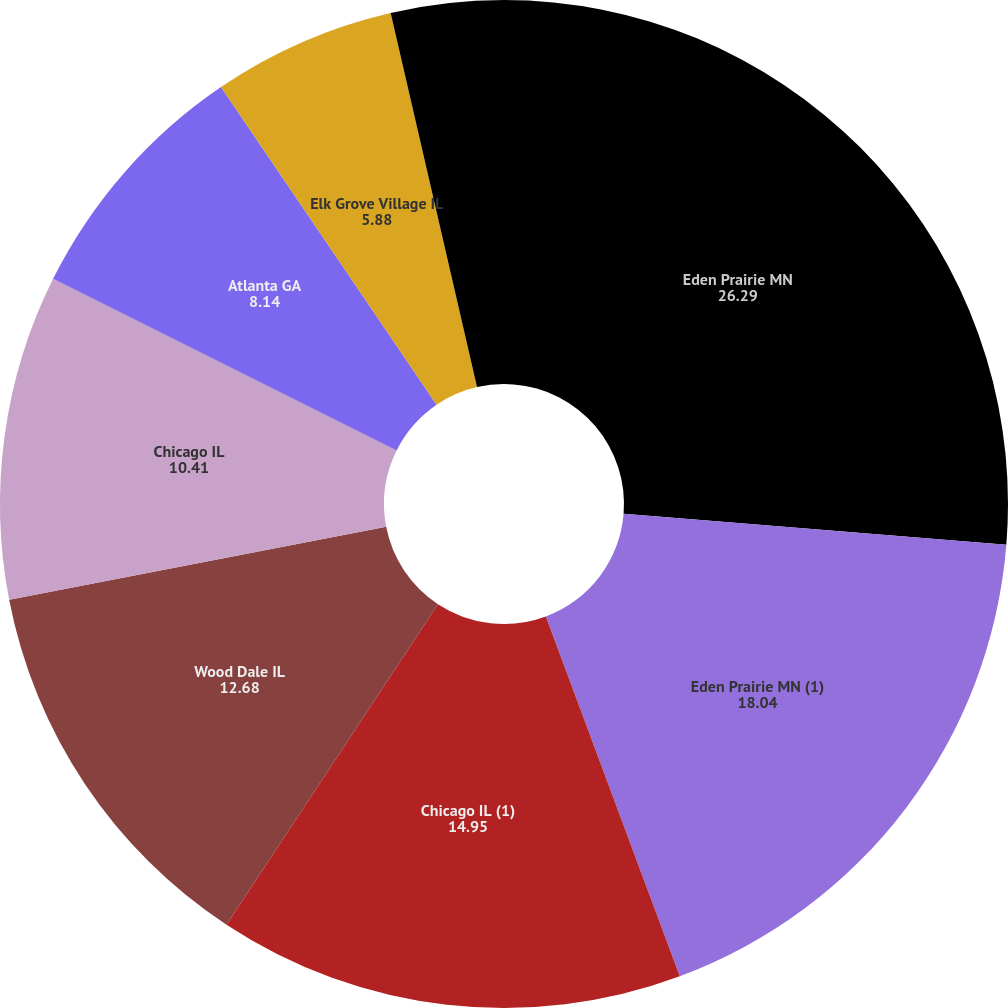Convert chart. <chart><loc_0><loc_0><loc_500><loc_500><pie_chart><fcel>Eden Prairie MN<fcel>Eden Prairie MN (1)<fcel>Chicago IL (1)<fcel>Wood Dale IL<fcel>Chicago IL<fcel>Atlanta GA<fcel>Elk Grove Village IL<fcel>Woodridge IL<nl><fcel>26.29%<fcel>18.04%<fcel>14.95%<fcel>12.68%<fcel>10.41%<fcel>8.14%<fcel>5.88%<fcel>3.61%<nl></chart> 